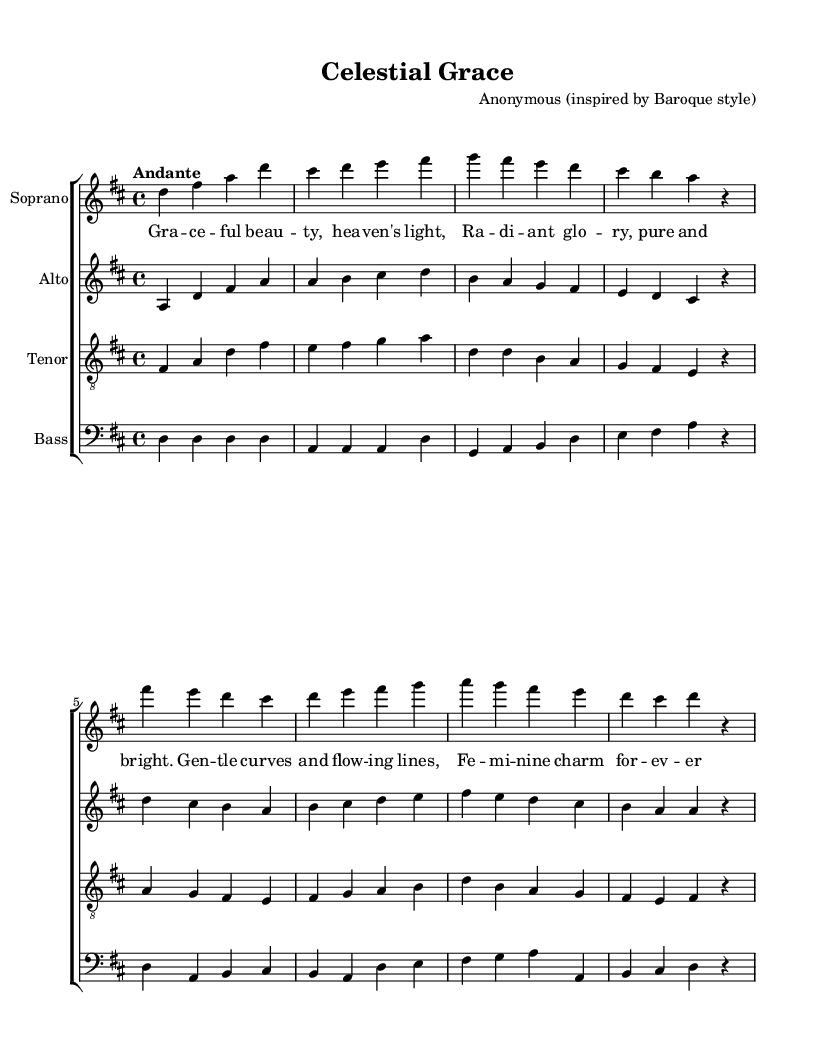What is the key signature of this music? The key signature is D major, which has two sharps: F# and C#. This can be identified by looking at the key signature notation at the beginning of the piece.
Answer: D major What is the time signature of this composition? The time signature is 4/4, which is indicated at the start of the score. This means there are four beats in each measure, and the quarter note receives one beat.
Answer: 4/4 What are the performing voices in this choir piece? The piece features four voices: Soprano, Alto, Tenor, and Bass. This information can be found in the staff labels that define the instrumental parts in the score.
Answer: Soprano, Alto, Tenor, Bass What is the tempo marking of this music? The tempo marking is "Andante," which indicates a moderate pace. This is explicitly written above the music at the start of the score, providing guidance for the performance speed.
Answer: Andante What is the text theme expressed in the lyrics? The lyrics celebrate feminine beauty and grace, describing qualities like "Graceful beauty" and "Radiant glory." This can be inferred from the verses that focus on the attributes and charm of femininity.
Answer: Feminine beauty and grace How many measures are in the soprano part? The soprano part consists of eight measures, which can be counted by looking at the bar lines that separate the measures in the score.
Answer: Eight measures What is the overall tonal center of this work? The overall tonal center is D major, which is established by the key signature and confirmed by the melodic and harmonic content throughout the piece. The piece frequently emphasizes the tonic note, D.
Answer: D major 